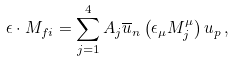Convert formula to latex. <formula><loc_0><loc_0><loc_500><loc_500>\epsilon \cdot M _ { f i } = \sum _ { j = 1 } ^ { 4 } A _ { j } \overline { u } _ { n } \left ( \epsilon _ { \mu } M _ { j } ^ { \mu } \right ) u _ { p } \, ,</formula> 